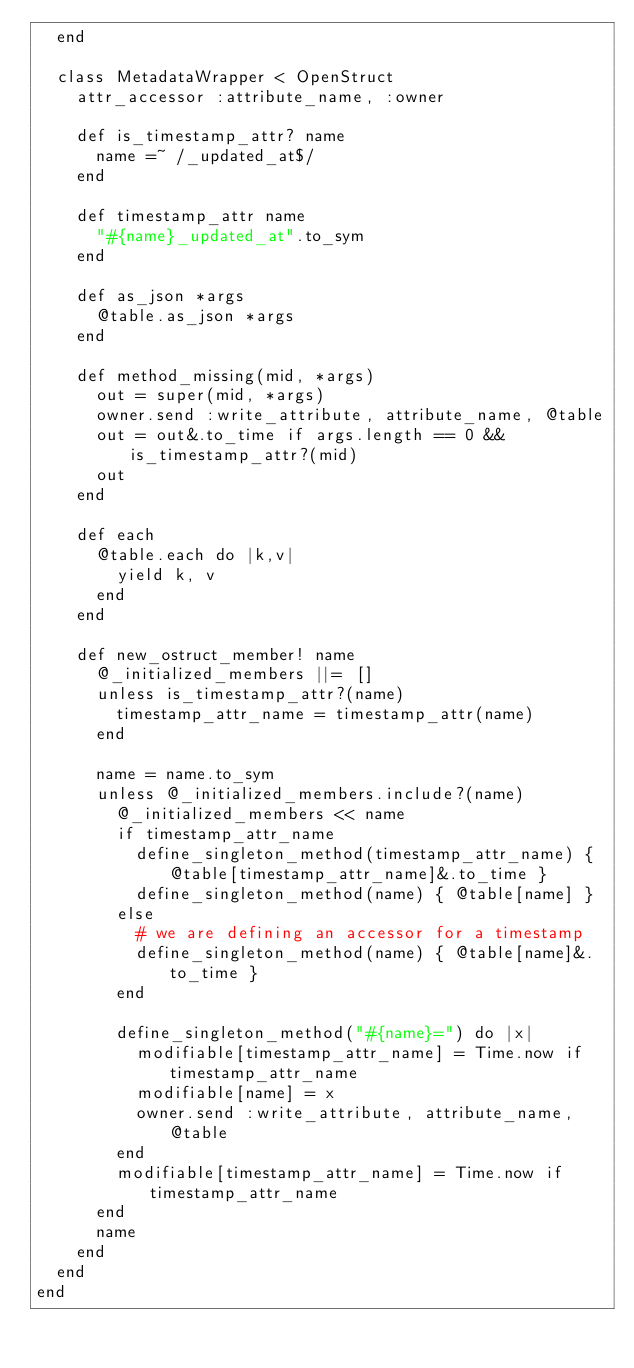Convert code to text. <code><loc_0><loc_0><loc_500><loc_500><_Ruby_>  end

  class MetadataWrapper < OpenStruct
    attr_accessor :attribute_name, :owner

    def is_timestamp_attr? name
      name =~ /_updated_at$/
    end

    def timestamp_attr name
      "#{name}_updated_at".to_sym
    end

    def as_json *args
      @table.as_json *args
    end

    def method_missing(mid, *args)
      out = super(mid, *args)
      owner.send :write_attribute, attribute_name, @table
      out = out&.to_time if args.length == 0 && is_timestamp_attr?(mid)
      out
    end

    def each
      @table.each do |k,v|
        yield k, v
      end
    end

    def new_ostruct_member! name
      @_initialized_members ||= []
      unless is_timestamp_attr?(name)
        timestamp_attr_name = timestamp_attr(name)
      end

      name = name.to_sym
      unless @_initialized_members.include?(name)
        @_initialized_members << name
        if timestamp_attr_name
          define_singleton_method(timestamp_attr_name) { @table[timestamp_attr_name]&.to_time }
          define_singleton_method(name) { @table[name] }
        else
          # we are defining an accessor for a timestamp
          define_singleton_method(name) { @table[name]&.to_time }
        end

        define_singleton_method("#{name}=") do |x|
          modifiable[timestamp_attr_name] = Time.now if timestamp_attr_name
          modifiable[name] = x
          owner.send :write_attribute, attribute_name, @table
        end
        modifiable[timestamp_attr_name] = Time.now if timestamp_attr_name
      end
      name
    end
  end
end
</code> 